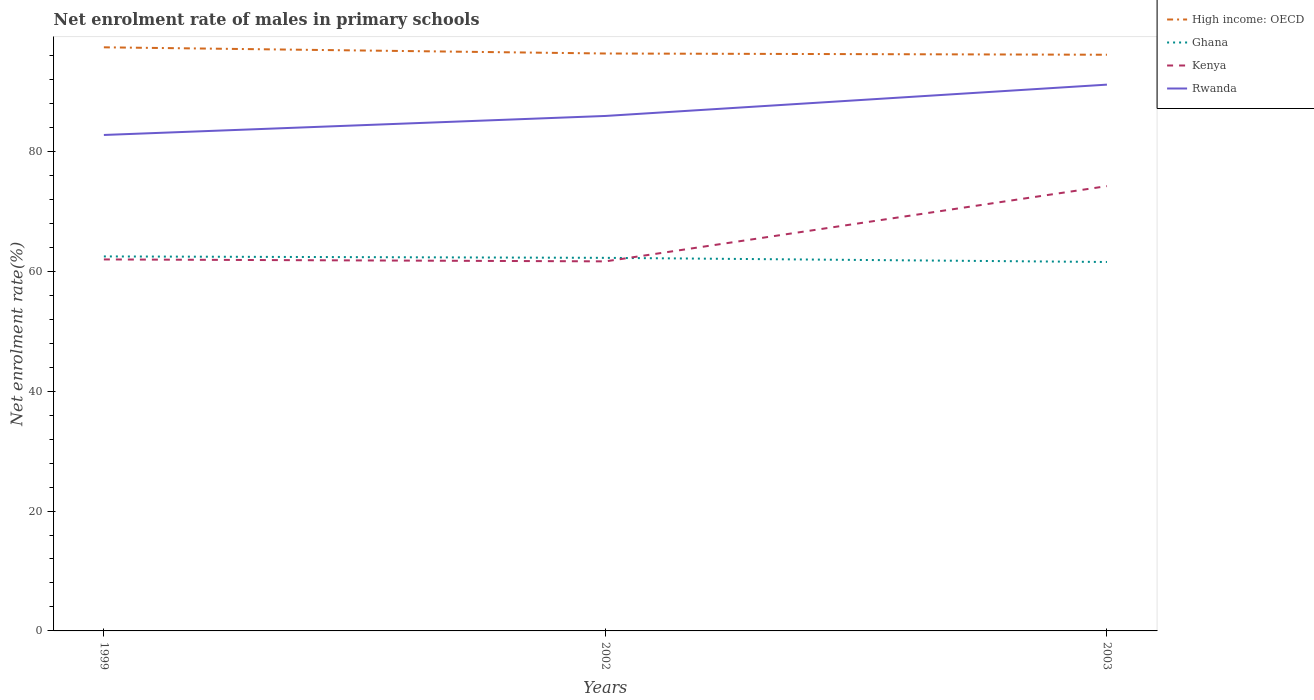How many different coloured lines are there?
Offer a terse response. 4. Does the line corresponding to Rwanda intersect with the line corresponding to High income: OECD?
Make the answer very short. No. Across all years, what is the maximum net enrolment rate of males in primary schools in Rwanda?
Make the answer very short. 82.73. In which year was the net enrolment rate of males in primary schools in Kenya maximum?
Provide a succinct answer. 2002. What is the total net enrolment rate of males in primary schools in Kenya in the graph?
Provide a short and direct response. -12.55. What is the difference between the highest and the second highest net enrolment rate of males in primary schools in Ghana?
Keep it short and to the point. 0.93. Is the net enrolment rate of males in primary schools in High income: OECD strictly greater than the net enrolment rate of males in primary schools in Rwanda over the years?
Offer a very short reply. No. How many lines are there?
Make the answer very short. 4. How many years are there in the graph?
Your answer should be compact. 3. Where does the legend appear in the graph?
Your response must be concise. Top right. How many legend labels are there?
Your answer should be compact. 4. What is the title of the graph?
Make the answer very short. Net enrolment rate of males in primary schools. What is the label or title of the X-axis?
Provide a succinct answer. Years. What is the label or title of the Y-axis?
Your answer should be compact. Net enrolment rate(%). What is the Net enrolment rate(%) of High income: OECD in 1999?
Provide a short and direct response. 97.35. What is the Net enrolment rate(%) in Ghana in 1999?
Make the answer very short. 62.47. What is the Net enrolment rate(%) of Kenya in 1999?
Give a very brief answer. 61.97. What is the Net enrolment rate(%) in Rwanda in 1999?
Your answer should be very brief. 82.73. What is the Net enrolment rate(%) in High income: OECD in 2002?
Your response must be concise. 96.32. What is the Net enrolment rate(%) of Ghana in 2002?
Your response must be concise. 62.23. What is the Net enrolment rate(%) of Kenya in 2002?
Provide a short and direct response. 61.64. What is the Net enrolment rate(%) of Rwanda in 2002?
Make the answer very short. 85.9. What is the Net enrolment rate(%) of High income: OECD in 2003?
Give a very brief answer. 96.11. What is the Net enrolment rate(%) of Ghana in 2003?
Provide a short and direct response. 61.54. What is the Net enrolment rate(%) in Kenya in 2003?
Provide a succinct answer. 74.2. What is the Net enrolment rate(%) of Rwanda in 2003?
Provide a short and direct response. 91.12. Across all years, what is the maximum Net enrolment rate(%) of High income: OECD?
Offer a terse response. 97.35. Across all years, what is the maximum Net enrolment rate(%) in Ghana?
Your response must be concise. 62.47. Across all years, what is the maximum Net enrolment rate(%) of Kenya?
Offer a very short reply. 74.2. Across all years, what is the maximum Net enrolment rate(%) in Rwanda?
Offer a terse response. 91.12. Across all years, what is the minimum Net enrolment rate(%) of High income: OECD?
Provide a short and direct response. 96.11. Across all years, what is the minimum Net enrolment rate(%) of Ghana?
Make the answer very short. 61.54. Across all years, what is the minimum Net enrolment rate(%) in Kenya?
Offer a terse response. 61.64. Across all years, what is the minimum Net enrolment rate(%) of Rwanda?
Provide a succinct answer. 82.73. What is the total Net enrolment rate(%) in High income: OECD in the graph?
Your response must be concise. 289.78. What is the total Net enrolment rate(%) of Ghana in the graph?
Provide a short and direct response. 186.24. What is the total Net enrolment rate(%) of Kenya in the graph?
Provide a succinct answer. 197.81. What is the total Net enrolment rate(%) in Rwanda in the graph?
Offer a very short reply. 259.75. What is the difference between the Net enrolment rate(%) in High income: OECD in 1999 and that in 2002?
Ensure brevity in your answer.  1.03. What is the difference between the Net enrolment rate(%) in Ghana in 1999 and that in 2002?
Provide a short and direct response. 0.24. What is the difference between the Net enrolment rate(%) in Kenya in 1999 and that in 2002?
Provide a short and direct response. 0.32. What is the difference between the Net enrolment rate(%) of Rwanda in 1999 and that in 2002?
Provide a succinct answer. -3.17. What is the difference between the Net enrolment rate(%) in High income: OECD in 1999 and that in 2003?
Keep it short and to the point. 1.24. What is the difference between the Net enrolment rate(%) in Ghana in 1999 and that in 2003?
Provide a succinct answer. 0.93. What is the difference between the Net enrolment rate(%) of Kenya in 1999 and that in 2003?
Your answer should be very brief. -12.23. What is the difference between the Net enrolment rate(%) of Rwanda in 1999 and that in 2003?
Offer a very short reply. -8.4. What is the difference between the Net enrolment rate(%) in High income: OECD in 2002 and that in 2003?
Keep it short and to the point. 0.21. What is the difference between the Net enrolment rate(%) in Ghana in 2002 and that in 2003?
Your answer should be very brief. 0.69. What is the difference between the Net enrolment rate(%) of Kenya in 2002 and that in 2003?
Ensure brevity in your answer.  -12.55. What is the difference between the Net enrolment rate(%) in Rwanda in 2002 and that in 2003?
Give a very brief answer. -5.22. What is the difference between the Net enrolment rate(%) of High income: OECD in 1999 and the Net enrolment rate(%) of Ghana in 2002?
Your response must be concise. 35.12. What is the difference between the Net enrolment rate(%) of High income: OECD in 1999 and the Net enrolment rate(%) of Kenya in 2002?
Offer a very short reply. 35.71. What is the difference between the Net enrolment rate(%) of High income: OECD in 1999 and the Net enrolment rate(%) of Rwanda in 2002?
Provide a short and direct response. 11.45. What is the difference between the Net enrolment rate(%) in Ghana in 1999 and the Net enrolment rate(%) in Kenya in 2002?
Ensure brevity in your answer.  0.82. What is the difference between the Net enrolment rate(%) in Ghana in 1999 and the Net enrolment rate(%) in Rwanda in 2002?
Give a very brief answer. -23.43. What is the difference between the Net enrolment rate(%) in Kenya in 1999 and the Net enrolment rate(%) in Rwanda in 2002?
Offer a very short reply. -23.93. What is the difference between the Net enrolment rate(%) of High income: OECD in 1999 and the Net enrolment rate(%) of Ghana in 2003?
Make the answer very short. 35.81. What is the difference between the Net enrolment rate(%) of High income: OECD in 1999 and the Net enrolment rate(%) of Kenya in 2003?
Your answer should be very brief. 23.15. What is the difference between the Net enrolment rate(%) in High income: OECD in 1999 and the Net enrolment rate(%) in Rwanda in 2003?
Give a very brief answer. 6.23. What is the difference between the Net enrolment rate(%) in Ghana in 1999 and the Net enrolment rate(%) in Kenya in 2003?
Offer a very short reply. -11.73. What is the difference between the Net enrolment rate(%) of Ghana in 1999 and the Net enrolment rate(%) of Rwanda in 2003?
Keep it short and to the point. -28.66. What is the difference between the Net enrolment rate(%) in Kenya in 1999 and the Net enrolment rate(%) in Rwanda in 2003?
Give a very brief answer. -29.16. What is the difference between the Net enrolment rate(%) of High income: OECD in 2002 and the Net enrolment rate(%) of Ghana in 2003?
Make the answer very short. 34.78. What is the difference between the Net enrolment rate(%) of High income: OECD in 2002 and the Net enrolment rate(%) of Kenya in 2003?
Your answer should be compact. 22.12. What is the difference between the Net enrolment rate(%) in High income: OECD in 2002 and the Net enrolment rate(%) in Rwanda in 2003?
Give a very brief answer. 5.19. What is the difference between the Net enrolment rate(%) of Ghana in 2002 and the Net enrolment rate(%) of Kenya in 2003?
Give a very brief answer. -11.96. What is the difference between the Net enrolment rate(%) in Ghana in 2002 and the Net enrolment rate(%) in Rwanda in 2003?
Make the answer very short. -28.89. What is the difference between the Net enrolment rate(%) of Kenya in 2002 and the Net enrolment rate(%) of Rwanda in 2003?
Keep it short and to the point. -29.48. What is the average Net enrolment rate(%) of High income: OECD per year?
Keep it short and to the point. 96.59. What is the average Net enrolment rate(%) in Ghana per year?
Give a very brief answer. 62.08. What is the average Net enrolment rate(%) in Kenya per year?
Keep it short and to the point. 65.94. What is the average Net enrolment rate(%) of Rwanda per year?
Ensure brevity in your answer.  86.58. In the year 1999, what is the difference between the Net enrolment rate(%) of High income: OECD and Net enrolment rate(%) of Ghana?
Provide a succinct answer. 34.88. In the year 1999, what is the difference between the Net enrolment rate(%) in High income: OECD and Net enrolment rate(%) in Kenya?
Provide a short and direct response. 35.38. In the year 1999, what is the difference between the Net enrolment rate(%) of High income: OECD and Net enrolment rate(%) of Rwanda?
Ensure brevity in your answer.  14.62. In the year 1999, what is the difference between the Net enrolment rate(%) of Ghana and Net enrolment rate(%) of Kenya?
Provide a succinct answer. 0.5. In the year 1999, what is the difference between the Net enrolment rate(%) of Ghana and Net enrolment rate(%) of Rwanda?
Your answer should be compact. -20.26. In the year 1999, what is the difference between the Net enrolment rate(%) of Kenya and Net enrolment rate(%) of Rwanda?
Offer a very short reply. -20.76. In the year 2002, what is the difference between the Net enrolment rate(%) of High income: OECD and Net enrolment rate(%) of Ghana?
Provide a succinct answer. 34.09. In the year 2002, what is the difference between the Net enrolment rate(%) in High income: OECD and Net enrolment rate(%) in Kenya?
Your response must be concise. 34.67. In the year 2002, what is the difference between the Net enrolment rate(%) in High income: OECD and Net enrolment rate(%) in Rwanda?
Keep it short and to the point. 10.42. In the year 2002, what is the difference between the Net enrolment rate(%) of Ghana and Net enrolment rate(%) of Kenya?
Keep it short and to the point. 0.59. In the year 2002, what is the difference between the Net enrolment rate(%) in Ghana and Net enrolment rate(%) in Rwanda?
Make the answer very short. -23.67. In the year 2002, what is the difference between the Net enrolment rate(%) in Kenya and Net enrolment rate(%) in Rwanda?
Keep it short and to the point. -24.26. In the year 2003, what is the difference between the Net enrolment rate(%) of High income: OECD and Net enrolment rate(%) of Ghana?
Offer a terse response. 34.57. In the year 2003, what is the difference between the Net enrolment rate(%) in High income: OECD and Net enrolment rate(%) in Kenya?
Make the answer very short. 21.91. In the year 2003, what is the difference between the Net enrolment rate(%) of High income: OECD and Net enrolment rate(%) of Rwanda?
Your response must be concise. 4.99. In the year 2003, what is the difference between the Net enrolment rate(%) in Ghana and Net enrolment rate(%) in Kenya?
Give a very brief answer. -12.66. In the year 2003, what is the difference between the Net enrolment rate(%) of Ghana and Net enrolment rate(%) of Rwanda?
Your answer should be very brief. -29.58. In the year 2003, what is the difference between the Net enrolment rate(%) in Kenya and Net enrolment rate(%) in Rwanda?
Your answer should be compact. -16.93. What is the ratio of the Net enrolment rate(%) in High income: OECD in 1999 to that in 2002?
Your answer should be very brief. 1.01. What is the ratio of the Net enrolment rate(%) in Ghana in 1999 to that in 2002?
Offer a terse response. 1. What is the ratio of the Net enrolment rate(%) in Rwanda in 1999 to that in 2002?
Your answer should be very brief. 0.96. What is the ratio of the Net enrolment rate(%) in High income: OECD in 1999 to that in 2003?
Offer a terse response. 1.01. What is the ratio of the Net enrolment rate(%) of Ghana in 1999 to that in 2003?
Make the answer very short. 1.02. What is the ratio of the Net enrolment rate(%) of Kenya in 1999 to that in 2003?
Offer a terse response. 0.84. What is the ratio of the Net enrolment rate(%) of Rwanda in 1999 to that in 2003?
Give a very brief answer. 0.91. What is the ratio of the Net enrolment rate(%) of High income: OECD in 2002 to that in 2003?
Make the answer very short. 1. What is the ratio of the Net enrolment rate(%) in Ghana in 2002 to that in 2003?
Your response must be concise. 1.01. What is the ratio of the Net enrolment rate(%) of Kenya in 2002 to that in 2003?
Provide a succinct answer. 0.83. What is the ratio of the Net enrolment rate(%) in Rwanda in 2002 to that in 2003?
Offer a very short reply. 0.94. What is the difference between the highest and the second highest Net enrolment rate(%) of High income: OECD?
Offer a very short reply. 1.03. What is the difference between the highest and the second highest Net enrolment rate(%) of Ghana?
Offer a very short reply. 0.24. What is the difference between the highest and the second highest Net enrolment rate(%) of Kenya?
Keep it short and to the point. 12.23. What is the difference between the highest and the second highest Net enrolment rate(%) of Rwanda?
Give a very brief answer. 5.22. What is the difference between the highest and the lowest Net enrolment rate(%) of High income: OECD?
Offer a very short reply. 1.24. What is the difference between the highest and the lowest Net enrolment rate(%) of Ghana?
Your answer should be compact. 0.93. What is the difference between the highest and the lowest Net enrolment rate(%) of Kenya?
Your answer should be compact. 12.55. What is the difference between the highest and the lowest Net enrolment rate(%) of Rwanda?
Provide a short and direct response. 8.4. 